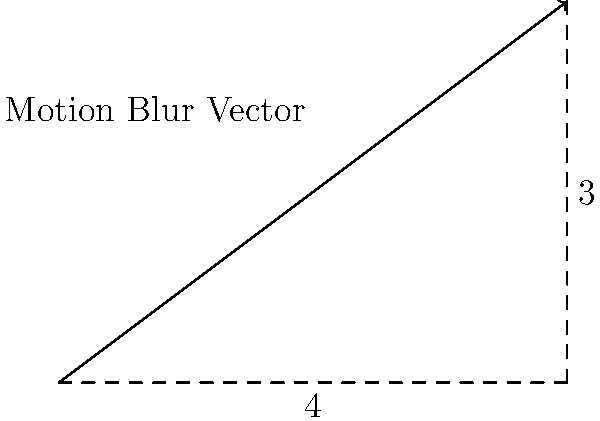In a fast-paced action sequence from a recent Surinamese film, the motion blur effect is represented by a vector with horizontal component 4 and vertical component 3 (in arbitrary units). Calculate the magnitude of this motion blur vector to quantify the intensity of the visual effect. To find the magnitude of the motion blur vector, we'll use the Pythagorean theorem:

1) The vector has a horizontal component of 4 and a vertical component of 3.

2) The magnitude of a vector is the square root of the sum of the squares of its components.

3) Let's call the magnitude $M$. We can express this mathematically as:

   $$M = \sqrt{x^2 + y^2}$$

   where $x$ is the horizontal component and $y$ is the vertical component.

4) Substituting our values:

   $$M = \sqrt{4^2 + 3^2}$$

5) Simplify:
   
   $$M = \sqrt{16 + 9} = \sqrt{25}$$

6) Calculate the final result:

   $$M = 5$$

Therefore, the magnitude of the motion blur vector is 5 units.
Answer: 5 units 